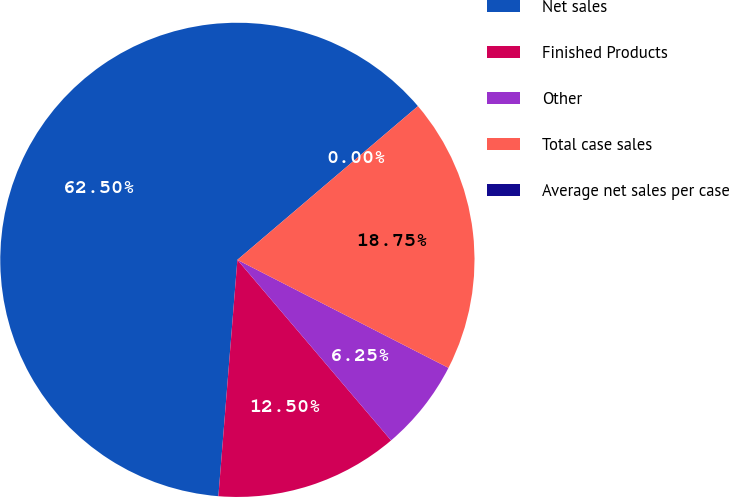Convert chart to OTSL. <chart><loc_0><loc_0><loc_500><loc_500><pie_chart><fcel>Net sales<fcel>Finished Products<fcel>Other<fcel>Total case sales<fcel>Average net sales per case<nl><fcel>62.5%<fcel>12.5%<fcel>6.25%<fcel>18.75%<fcel>0.0%<nl></chart> 